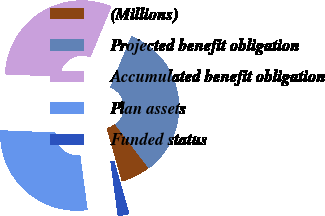Convert chart. <chart><loc_0><loc_0><loc_500><loc_500><pie_chart><fcel>(Millions)<fcel>Projected benefit obligation<fcel>Accumulated benefit obligation<fcel>Plan assets<fcel>Funded status<nl><fcel>6.0%<fcel>33.35%<fcel>30.57%<fcel>27.79%<fcel>2.3%<nl></chart> 